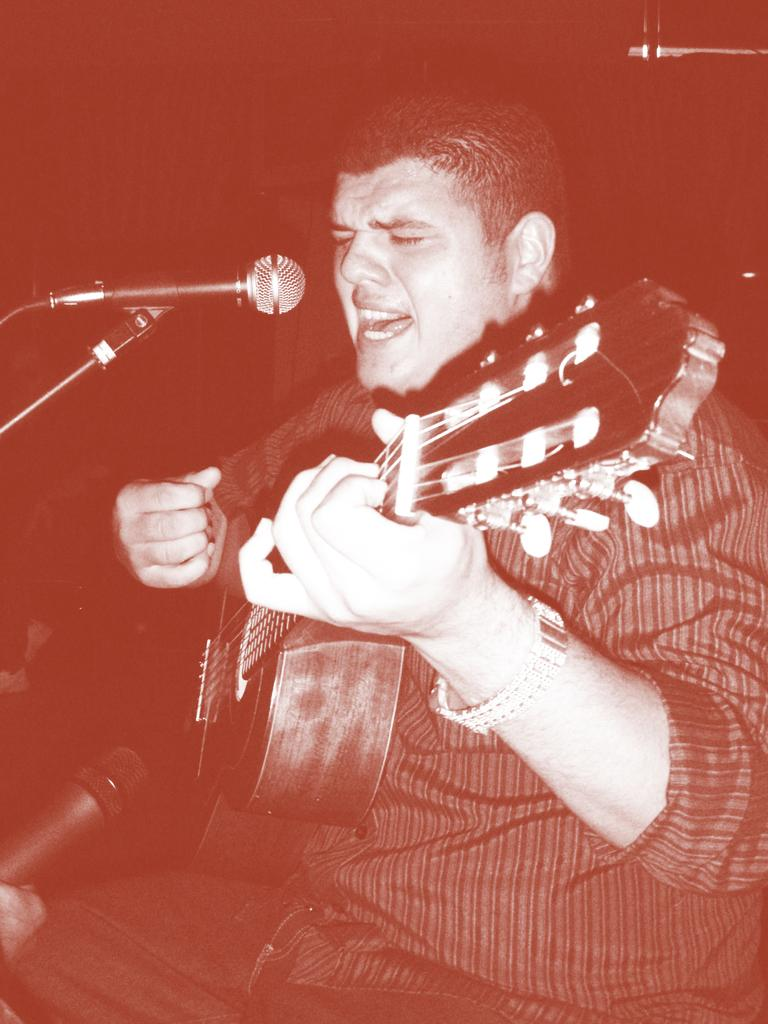What is the main subject of the image? There is a man in the image. What is the man doing in the image? The man is sitting and playing a guitar. Are there any objects related to music or performance in the image? Yes, there are microphones in the image. How many snails can be seen crawling on the guitar in the image? There are no snails present in the image; the man is playing a guitar without any snails on it. 